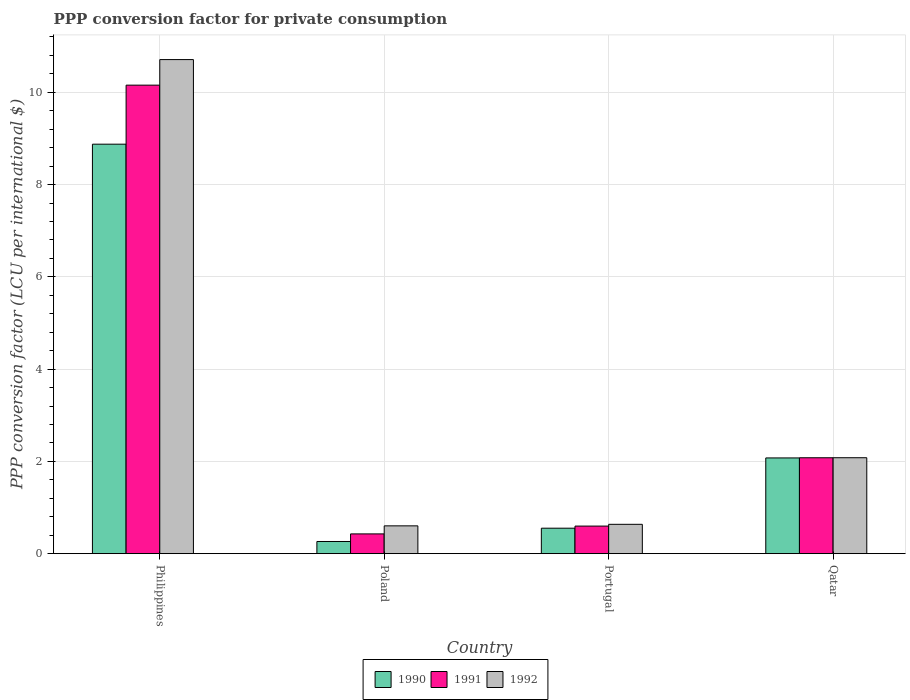How many groups of bars are there?
Keep it short and to the point. 4. Are the number of bars on each tick of the X-axis equal?
Offer a terse response. Yes. How many bars are there on the 4th tick from the left?
Your response must be concise. 3. How many bars are there on the 1st tick from the right?
Provide a succinct answer. 3. What is the label of the 4th group of bars from the left?
Offer a very short reply. Qatar. In how many cases, is the number of bars for a given country not equal to the number of legend labels?
Offer a terse response. 0. What is the PPP conversion factor for private consumption in 1992 in Portugal?
Your answer should be very brief. 0.64. Across all countries, what is the maximum PPP conversion factor for private consumption in 1991?
Your answer should be compact. 10.15. Across all countries, what is the minimum PPP conversion factor for private consumption in 1991?
Offer a terse response. 0.43. What is the total PPP conversion factor for private consumption in 1992 in the graph?
Your answer should be compact. 14.03. What is the difference between the PPP conversion factor for private consumption in 1990 in Portugal and that in Qatar?
Your response must be concise. -1.52. What is the difference between the PPP conversion factor for private consumption in 1992 in Qatar and the PPP conversion factor for private consumption in 1991 in Poland?
Provide a succinct answer. 1.65. What is the average PPP conversion factor for private consumption in 1992 per country?
Keep it short and to the point. 3.51. What is the difference between the PPP conversion factor for private consumption of/in 1991 and PPP conversion factor for private consumption of/in 1992 in Portugal?
Your response must be concise. -0.04. In how many countries, is the PPP conversion factor for private consumption in 1990 greater than 9.2 LCU?
Ensure brevity in your answer.  0. What is the ratio of the PPP conversion factor for private consumption in 1991 in Poland to that in Qatar?
Offer a terse response. 0.21. Is the difference between the PPP conversion factor for private consumption in 1991 in Philippines and Qatar greater than the difference between the PPP conversion factor for private consumption in 1992 in Philippines and Qatar?
Your answer should be very brief. No. What is the difference between the highest and the second highest PPP conversion factor for private consumption in 1992?
Keep it short and to the point. -10.07. What is the difference between the highest and the lowest PPP conversion factor for private consumption in 1990?
Your response must be concise. 8.61. What does the 1st bar from the right in Philippines represents?
Offer a very short reply. 1992. How many bars are there?
Provide a succinct answer. 12. Are all the bars in the graph horizontal?
Your answer should be very brief. No. How many countries are there in the graph?
Offer a very short reply. 4. Does the graph contain any zero values?
Your answer should be very brief. No. Does the graph contain grids?
Provide a succinct answer. Yes. How many legend labels are there?
Provide a short and direct response. 3. What is the title of the graph?
Your answer should be very brief. PPP conversion factor for private consumption. What is the label or title of the Y-axis?
Ensure brevity in your answer.  PPP conversion factor (LCU per international $). What is the PPP conversion factor (LCU per international $) in 1990 in Philippines?
Provide a short and direct response. 8.88. What is the PPP conversion factor (LCU per international $) of 1991 in Philippines?
Offer a very short reply. 10.15. What is the PPP conversion factor (LCU per international $) of 1992 in Philippines?
Provide a short and direct response. 10.71. What is the PPP conversion factor (LCU per international $) in 1990 in Poland?
Ensure brevity in your answer.  0.26. What is the PPP conversion factor (LCU per international $) in 1991 in Poland?
Offer a terse response. 0.43. What is the PPP conversion factor (LCU per international $) in 1992 in Poland?
Your answer should be compact. 0.6. What is the PPP conversion factor (LCU per international $) in 1990 in Portugal?
Provide a short and direct response. 0.55. What is the PPP conversion factor (LCU per international $) in 1991 in Portugal?
Keep it short and to the point. 0.6. What is the PPP conversion factor (LCU per international $) of 1992 in Portugal?
Make the answer very short. 0.64. What is the PPP conversion factor (LCU per international $) of 1990 in Qatar?
Your answer should be very brief. 2.08. What is the PPP conversion factor (LCU per international $) of 1991 in Qatar?
Give a very brief answer. 2.08. What is the PPP conversion factor (LCU per international $) of 1992 in Qatar?
Offer a very short reply. 2.08. Across all countries, what is the maximum PPP conversion factor (LCU per international $) of 1990?
Make the answer very short. 8.88. Across all countries, what is the maximum PPP conversion factor (LCU per international $) of 1991?
Make the answer very short. 10.15. Across all countries, what is the maximum PPP conversion factor (LCU per international $) in 1992?
Give a very brief answer. 10.71. Across all countries, what is the minimum PPP conversion factor (LCU per international $) in 1990?
Your answer should be very brief. 0.26. Across all countries, what is the minimum PPP conversion factor (LCU per international $) of 1991?
Your answer should be very brief. 0.43. Across all countries, what is the minimum PPP conversion factor (LCU per international $) of 1992?
Your answer should be very brief. 0.6. What is the total PPP conversion factor (LCU per international $) in 1990 in the graph?
Your answer should be compact. 11.77. What is the total PPP conversion factor (LCU per international $) in 1991 in the graph?
Keep it short and to the point. 13.26. What is the total PPP conversion factor (LCU per international $) in 1992 in the graph?
Your response must be concise. 14.03. What is the difference between the PPP conversion factor (LCU per international $) in 1990 in Philippines and that in Poland?
Make the answer very short. 8.61. What is the difference between the PPP conversion factor (LCU per international $) of 1991 in Philippines and that in Poland?
Your response must be concise. 9.73. What is the difference between the PPP conversion factor (LCU per international $) in 1992 in Philippines and that in Poland?
Provide a short and direct response. 10.11. What is the difference between the PPP conversion factor (LCU per international $) of 1990 in Philippines and that in Portugal?
Provide a short and direct response. 8.32. What is the difference between the PPP conversion factor (LCU per international $) in 1991 in Philippines and that in Portugal?
Ensure brevity in your answer.  9.56. What is the difference between the PPP conversion factor (LCU per international $) in 1992 in Philippines and that in Portugal?
Your response must be concise. 10.07. What is the difference between the PPP conversion factor (LCU per international $) in 1990 in Philippines and that in Qatar?
Ensure brevity in your answer.  6.8. What is the difference between the PPP conversion factor (LCU per international $) in 1991 in Philippines and that in Qatar?
Ensure brevity in your answer.  8.08. What is the difference between the PPP conversion factor (LCU per international $) of 1992 in Philippines and that in Qatar?
Keep it short and to the point. 8.63. What is the difference between the PPP conversion factor (LCU per international $) of 1990 in Poland and that in Portugal?
Keep it short and to the point. -0.29. What is the difference between the PPP conversion factor (LCU per international $) of 1991 in Poland and that in Portugal?
Provide a succinct answer. -0.17. What is the difference between the PPP conversion factor (LCU per international $) of 1992 in Poland and that in Portugal?
Your response must be concise. -0.03. What is the difference between the PPP conversion factor (LCU per international $) in 1990 in Poland and that in Qatar?
Provide a short and direct response. -1.81. What is the difference between the PPP conversion factor (LCU per international $) of 1991 in Poland and that in Qatar?
Keep it short and to the point. -1.65. What is the difference between the PPP conversion factor (LCU per international $) of 1992 in Poland and that in Qatar?
Provide a succinct answer. -1.48. What is the difference between the PPP conversion factor (LCU per international $) in 1990 in Portugal and that in Qatar?
Offer a terse response. -1.52. What is the difference between the PPP conversion factor (LCU per international $) in 1991 in Portugal and that in Qatar?
Give a very brief answer. -1.48. What is the difference between the PPP conversion factor (LCU per international $) in 1992 in Portugal and that in Qatar?
Your answer should be compact. -1.44. What is the difference between the PPP conversion factor (LCU per international $) of 1990 in Philippines and the PPP conversion factor (LCU per international $) of 1991 in Poland?
Your answer should be very brief. 8.45. What is the difference between the PPP conversion factor (LCU per international $) of 1990 in Philippines and the PPP conversion factor (LCU per international $) of 1992 in Poland?
Your answer should be very brief. 8.27. What is the difference between the PPP conversion factor (LCU per international $) of 1991 in Philippines and the PPP conversion factor (LCU per international $) of 1992 in Poland?
Provide a short and direct response. 9.55. What is the difference between the PPP conversion factor (LCU per international $) in 1990 in Philippines and the PPP conversion factor (LCU per international $) in 1991 in Portugal?
Your answer should be compact. 8.28. What is the difference between the PPP conversion factor (LCU per international $) in 1990 in Philippines and the PPP conversion factor (LCU per international $) in 1992 in Portugal?
Give a very brief answer. 8.24. What is the difference between the PPP conversion factor (LCU per international $) in 1991 in Philippines and the PPP conversion factor (LCU per international $) in 1992 in Portugal?
Give a very brief answer. 9.52. What is the difference between the PPP conversion factor (LCU per international $) of 1990 in Philippines and the PPP conversion factor (LCU per international $) of 1991 in Qatar?
Keep it short and to the point. 6.8. What is the difference between the PPP conversion factor (LCU per international $) of 1990 in Philippines and the PPP conversion factor (LCU per international $) of 1992 in Qatar?
Your answer should be very brief. 6.8. What is the difference between the PPP conversion factor (LCU per international $) of 1991 in Philippines and the PPP conversion factor (LCU per international $) of 1992 in Qatar?
Give a very brief answer. 8.08. What is the difference between the PPP conversion factor (LCU per international $) in 1990 in Poland and the PPP conversion factor (LCU per international $) in 1991 in Portugal?
Offer a very short reply. -0.33. What is the difference between the PPP conversion factor (LCU per international $) of 1990 in Poland and the PPP conversion factor (LCU per international $) of 1992 in Portugal?
Provide a succinct answer. -0.37. What is the difference between the PPP conversion factor (LCU per international $) in 1991 in Poland and the PPP conversion factor (LCU per international $) in 1992 in Portugal?
Offer a terse response. -0.21. What is the difference between the PPP conversion factor (LCU per international $) of 1990 in Poland and the PPP conversion factor (LCU per international $) of 1991 in Qatar?
Your response must be concise. -1.81. What is the difference between the PPP conversion factor (LCU per international $) in 1990 in Poland and the PPP conversion factor (LCU per international $) in 1992 in Qatar?
Provide a succinct answer. -1.82. What is the difference between the PPP conversion factor (LCU per international $) in 1991 in Poland and the PPP conversion factor (LCU per international $) in 1992 in Qatar?
Keep it short and to the point. -1.65. What is the difference between the PPP conversion factor (LCU per international $) of 1990 in Portugal and the PPP conversion factor (LCU per international $) of 1991 in Qatar?
Your answer should be very brief. -1.53. What is the difference between the PPP conversion factor (LCU per international $) of 1990 in Portugal and the PPP conversion factor (LCU per international $) of 1992 in Qatar?
Offer a terse response. -1.53. What is the difference between the PPP conversion factor (LCU per international $) of 1991 in Portugal and the PPP conversion factor (LCU per international $) of 1992 in Qatar?
Give a very brief answer. -1.48. What is the average PPP conversion factor (LCU per international $) in 1990 per country?
Ensure brevity in your answer.  2.94. What is the average PPP conversion factor (LCU per international $) of 1991 per country?
Your answer should be compact. 3.31. What is the average PPP conversion factor (LCU per international $) of 1992 per country?
Provide a succinct answer. 3.51. What is the difference between the PPP conversion factor (LCU per international $) of 1990 and PPP conversion factor (LCU per international $) of 1991 in Philippines?
Offer a terse response. -1.28. What is the difference between the PPP conversion factor (LCU per international $) in 1990 and PPP conversion factor (LCU per international $) in 1992 in Philippines?
Offer a terse response. -1.83. What is the difference between the PPP conversion factor (LCU per international $) in 1991 and PPP conversion factor (LCU per international $) in 1992 in Philippines?
Offer a very short reply. -0.55. What is the difference between the PPP conversion factor (LCU per international $) in 1990 and PPP conversion factor (LCU per international $) in 1991 in Poland?
Give a very brief answer. -0.16. What is the difference between the PPP conversion factor (LCU per international $) in 1990 and PPP conversion factor (LCU per international $) in 1992 in Poland?
Your answer should be very brief. -0.34. What is the difference between the PPP conversion factor (LCU per international $) of 1991 and PPP conversion factor (LCU per international $) of 1992 in Poland?
Provide a short and direct response. -0.17. What is the difference between the PPP conversion factor (LCU per international $) of 1990 and PPP conversion factor (LCU per international $) of 1991 in Portugal?
Ensure brevity in your answer.  -0.05. What is the difference between the PPP conversion factor (LCU per international $) in 1990 and PPP conversion factor (LCU per international $) in 1992 in Portugal?
Provide a succinct answer. -0.08. What is the difference between the PPP conversion factor (LCU per international $) in 1991 and PPP conversion factor (LCU per international $) in 1992 in Portugal?
Give a very brief answer. -0.04. What is the difference between the PPP conversion factor (LCU per international $) of 1990 and PPP conversion factor (LCU per international $) of 1991 in Qatar?
Offer a very short reply. -0. What is the difference between the PPP conversion factor (LCU per international $) of 1990 and PPP conversion factor (LCU per international $) of 1992 in Qatar?
Your answer should be compact. -0. What is the difference between the PPP conversion factor (LCU per international $) of 1991 and PPP conversion factor (LCU per international $) of 1992 in Qatar?
Your answer should be compact. -0. What is the ratio of the PPP conversion factor (LCU per international $) in 1990 in Philippines to that in Poland?
Ensure brevity in your answer.  33.67. What is the ratio of the PPP conversion factor (LCU per international $) in 1991 in Philippines to that in Poland?
Provide a succinct answer. 23.71. What is the ratio of the PPP conversion factor (LCU per international $) in 1992 in Philippines to that in Poland?
Your answer should be compact. 17.77. What is the ratio of the PPP conversion factor (LCU per international $) in 1990 in Philippines to that in Portugal?
Your answer should be compact. 16.08. What is the ratio of the PPP conversion factor (LCU per international $) in 1991 in Philippines to that in Portugal?
Keep it short and to the point. 16.99. What is the ratio of the PPP conversion factor (LCU per international $) in 1992 in Philippines to that in Portugal?
Your answer should be compact. 16.84. What is the ratio of the PPP conversion factor (LCU per international $) of 1990 in Philippines to that in Qatar?
Make the answer very short. 4.28. What is the ratio of the PPP conversion factor (LCU per international $) in 1991 in Philippines to that in Qatar?
Provide a short and direct response. 4.89. What is the ratio of the PPP conversion factor (LCU per international $) of 1992 in Philippines to that in Qatar?
Give a very brief answer. 5.15. What is the ratio of the PPP conversion factor (LCU per international $) in 1990 in Poland to that in Portugal?
Ensure brevity in your answer.  0.48. What is the ratio of the PPP conversion factor (LCU per international $) of 1991 in Poland to that in Portugal?
Offer a very short reply. 0.72. What is the ratio of the PPP conversion factor (LCU per international $) in 1992 in Poland to that in Portugal?
Ensure brevity in your answer.  0.95. What is the ratio of the PPP conversion factor (LCU per international $) of 1990 in Poland to that in Qatar?
Offer a terse response. 0.13. What is the ratio of the PPP conversion factor (LCU per international $) of 1991 in Poland to that in Qatar?
Keep it short and to the point. 0.21. What is the ratio of the PPP conversion factor (LCU per international $) of 1992 in Poland to that in Qatar?
Your response must be concise. 0.29. What is the ratio of the PPP conversion factor (LCU per international $) of 1990 in Portugal to that in Qatar?
Provide a short and direct response. 0.27. What is the ratio of the PPP conversion factor (LCU per international $) in 1991 in Portugal to that in Qatar?
Offer a very short reply. 0.29. What is the ratio of the PPP conversion factor (LCU per international $) of 1992 in Portugal to that in Qatar?
Provide a short and direct response. 0.31. What is the difference between the highest and the second highest PPP conversion factor (LCU per international $) in 1990?
Provide a succinct answer. 6.8. What is the difference between the highest and the second highest PPP conversion factor (LCU per international $) in 1991?
Your answer should be very brief. 8.08. What is the difference between the highest and the second highest PPP conversion factor (LCU per international $) of 1992?
Offer a very short reply. 8.63. What is the difference between the highest and the lowest PPP conversion factor (LCU per international $) in 1990?
Your answer should be compact. 8.61. What is the difference between the highest and the lowest PPP conversion factor (LCU per international $) in 1991?
Your answer should be compact. 9.73. What is the difference between the highest and the lowest PPP conversion factor (LCU per international $) of 1992?
Your answer should be very brief. 10.11. 